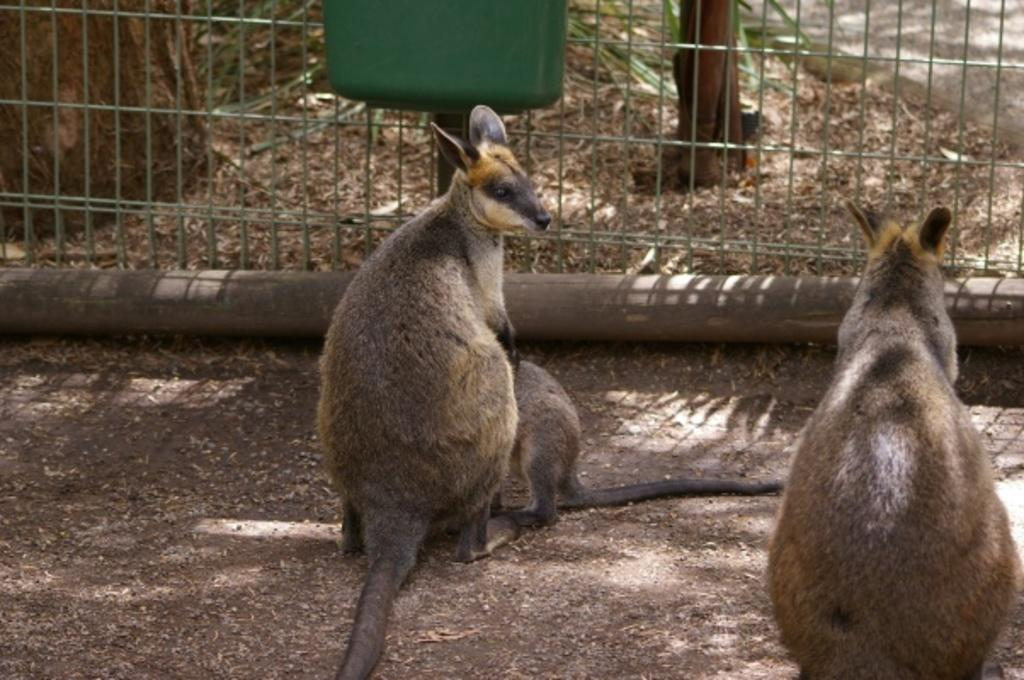What types of living organisms can be seen in the image? There are animals in the image. What can be seen in the background of the image? There is a fence in the background of the image. What type of motion can be observed in the image involving a bat and a needle? There is no bat or needle present in the image, so no such motion can be observed. 